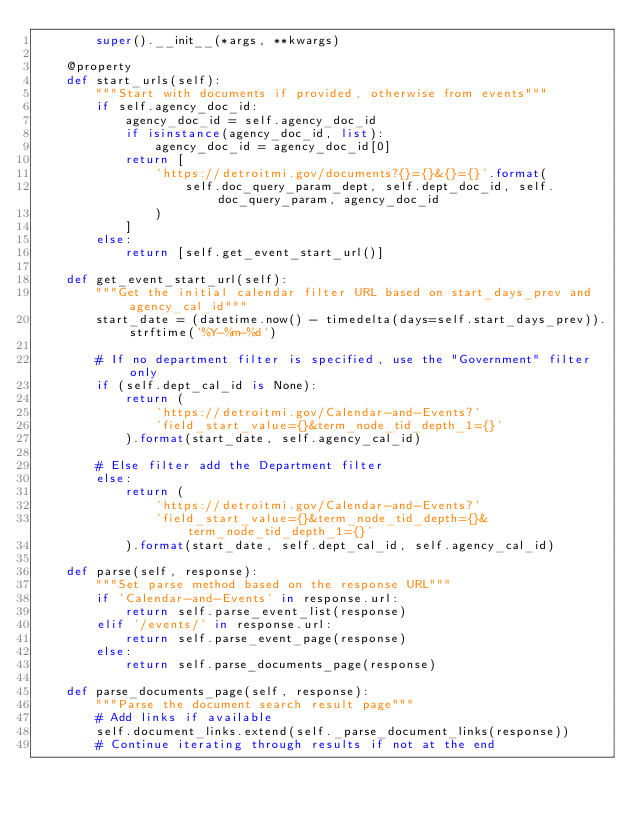Convert code to text. <code><loc_0><loc_0><loc_500><loc_500><_Python_>        super().__init__(*args, **kwargs)

    @property
    def start_urls(self):
        """Start with documents if provided, otherwise from events"""
        if self.agency_doc_id:
            agency_doc_id = self.agency_doc_id
            if isinstance(agency_doc_id, list):
                agency_doc_id = agency_doc_id[0]
            return [
                'https://detroitmi.gov/documents?{}={}&{}={}'.format(
                    self.doc_query_param_dept, self.dept_doc_id, self.doc_query_param, agency_doc_id
                )
            ]
        else:
            return [self.get_event_start_url()]

    def get_event_start_url(self):
        """Get the initial calendar filter URL based on start_days_prev and agency_cal_id"""
        start_date = (datetime.now() - timedelta(days=self.start_days_prev)).strftime('%Y-%m-%d')

        # If no department filter is specified, use the "Government" filter only
        if (self.dept_cal_id is None):
            return (
                'https://detroitmi.gov/Calendar-and-Events?'
                'field_start_value={}&term_node_tid_depth_1={}'
            ).format(start_date, self.agency_cal_id)

        # Else filter add the Department filter
        else:
            return (
                'https://detroitmi.gov/Calendar-and-Events?'
                'field_start_value={}&term_node_tid_depth={}&term_node_tid_depth_1={}'
            ).format(start_date, self.dept_cal_id, self.agency_cal_id)

    def parse(self, response):
        """Set parse method based on the response URL"""
        if 'Calendar-and-Events' in response.url:
            return self.parse_event_list(response)
        elif '/events/' in response.url:
            return self.parse_event_page(response)
        else:
            return self.parse_documents_page(response)

    def parse_documents_page(self, response):
        """Parse the document search result page"""
        # Add links if available
        self.document_links.extend(self._parse_document_links(response))
        # Continue iterating through results if not at the end</code> 